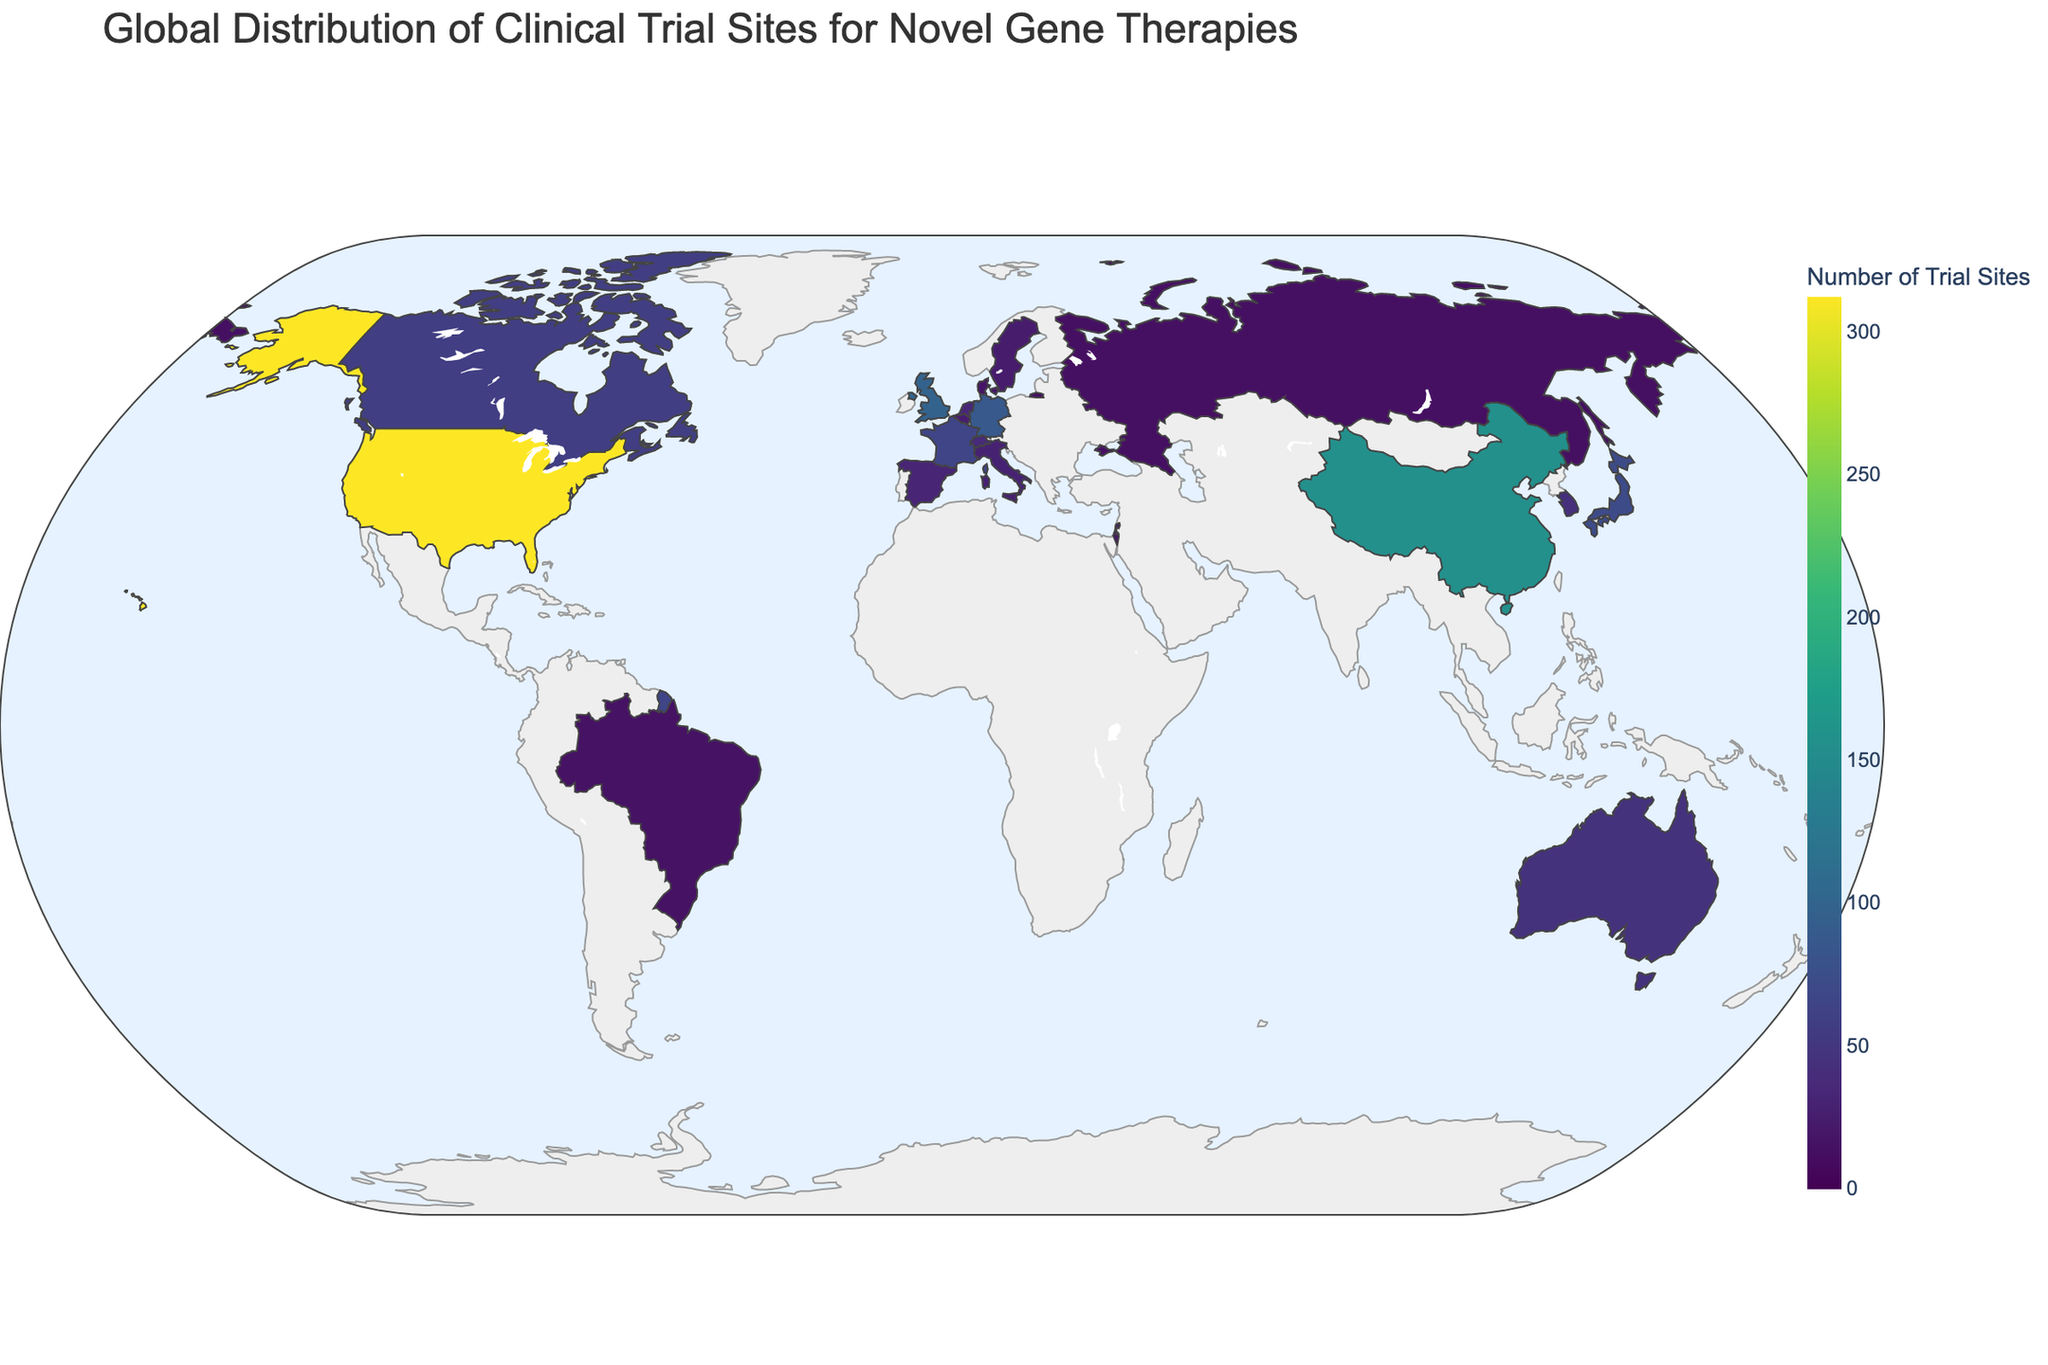What's the title of the figure? The title is usually located at the top of the figure and provides a summary of what the figure is about. Reading the title of the figure gives context to the data presented.
Answer: Global Distribution of Clinical Trial Sites for Novel Gene Therapies Which country has the highest number of trial sites? Look for the country with the darkest color on the choropleth map and check the color bar to confirm it has the highest number of trial sites.
Answer: United States How many trial sites does Germany have compared to the United Kingdom? To compare, find both countries on the figure and read their respective numbers of trial sites. Germany has 87 and the United Kingdom has 98, so calculate the difference (98 - 87).
Answer: 11 fewer What is the combined number of trial sites for the top three countries? Identify the top three countries (United States, China, United Kingdom) and sum their trial site numbers (312 + 156 + 98).
Answer: 566 Which country in the figure has the fewest trial sites? Find the country with the lightest color on the map, and check the color bar to confirm its corresponding trial site number.
Answer: Singapore What is the average number of trial sites for France, Canada, and Australia? Sum the number of trial sites for France, Canada, and Australia (65 + 58 + 45) and divide by 3.
Answer: 56 What is the color scale used in the figure? The color scale maps the number of trial sites to a color gradient and is specified as Viridis in the figure.
Answer: Viridis Which two neighboring European countries have a combined total of more than 50 trial sites? Look for neighboring countries in Europe on the map and sum their trial site numbers. For example, Belgium (26) and Netherlands (34), which combined have 60 trial sites.
Answer: Belgium and Netherlands How does the number of trial sites in Japan compare to South Korea? Locate Japan and South Korea on the figure and compare their trial site numbers. Japan has 72 and South Korea has 43.
Answer: Japan has 29 more Which region, North America or Europe, appears to have a higher concentration of trial sites? Compare the number of highly colored countries in North America and Europe. North America, with the United States and Canada, versus multiple European countries with significant numbers.
Answer: Europe 